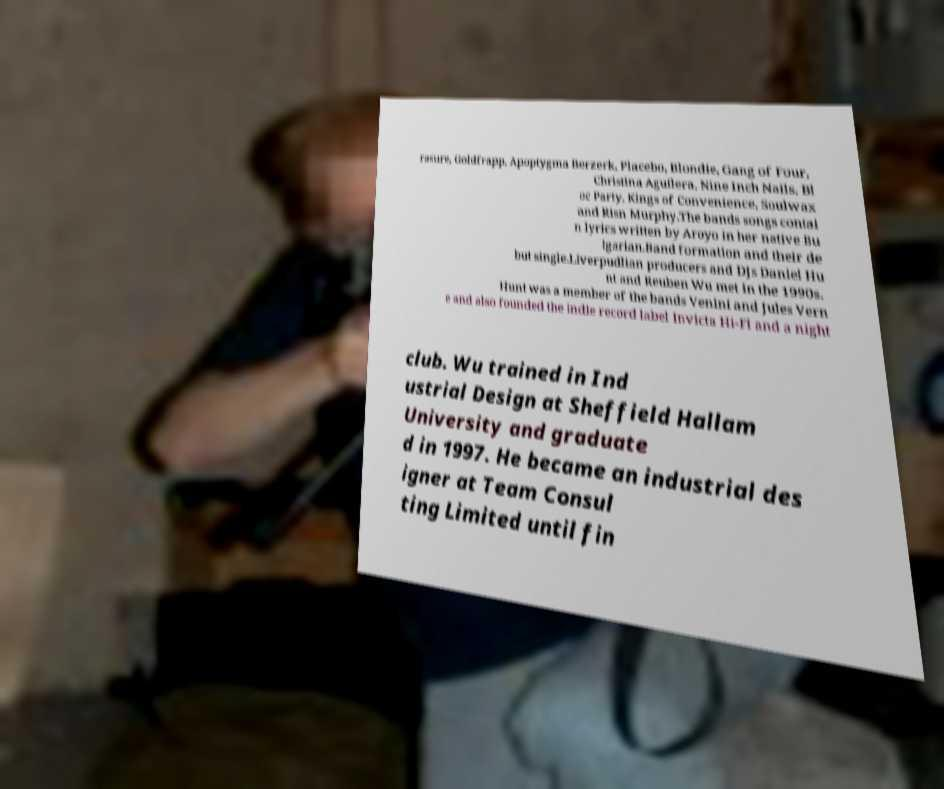There's text embedded in this image that I need extracted. Can you transcribe it verbatim? rasure, Goldfrapp, Apoptygma Berzerk, Placebo, Blondie, Gang of Four, Christina Aguilera, Nine Inch Nails, Bl oc Party, Kings of Convenience, Soulwax and Risn Murphy.The bands songs contai n lyrics written by Aroyo in her native Bu lgarian.Band formation and their de but single.Liverpudlian producers and DJs Daniel Hu nt and Reuben Wu met in the 1990s. Hunt was a member of the bands Venini and Jules Vern e and also founded the indie record label Invicta Hi-Fi and a night club. Wu trained in Ind ustrial Design at Sheffield Hallam University and graduate d in 1997. He became an industrial des igner at Team Consul ting Limited until fin 